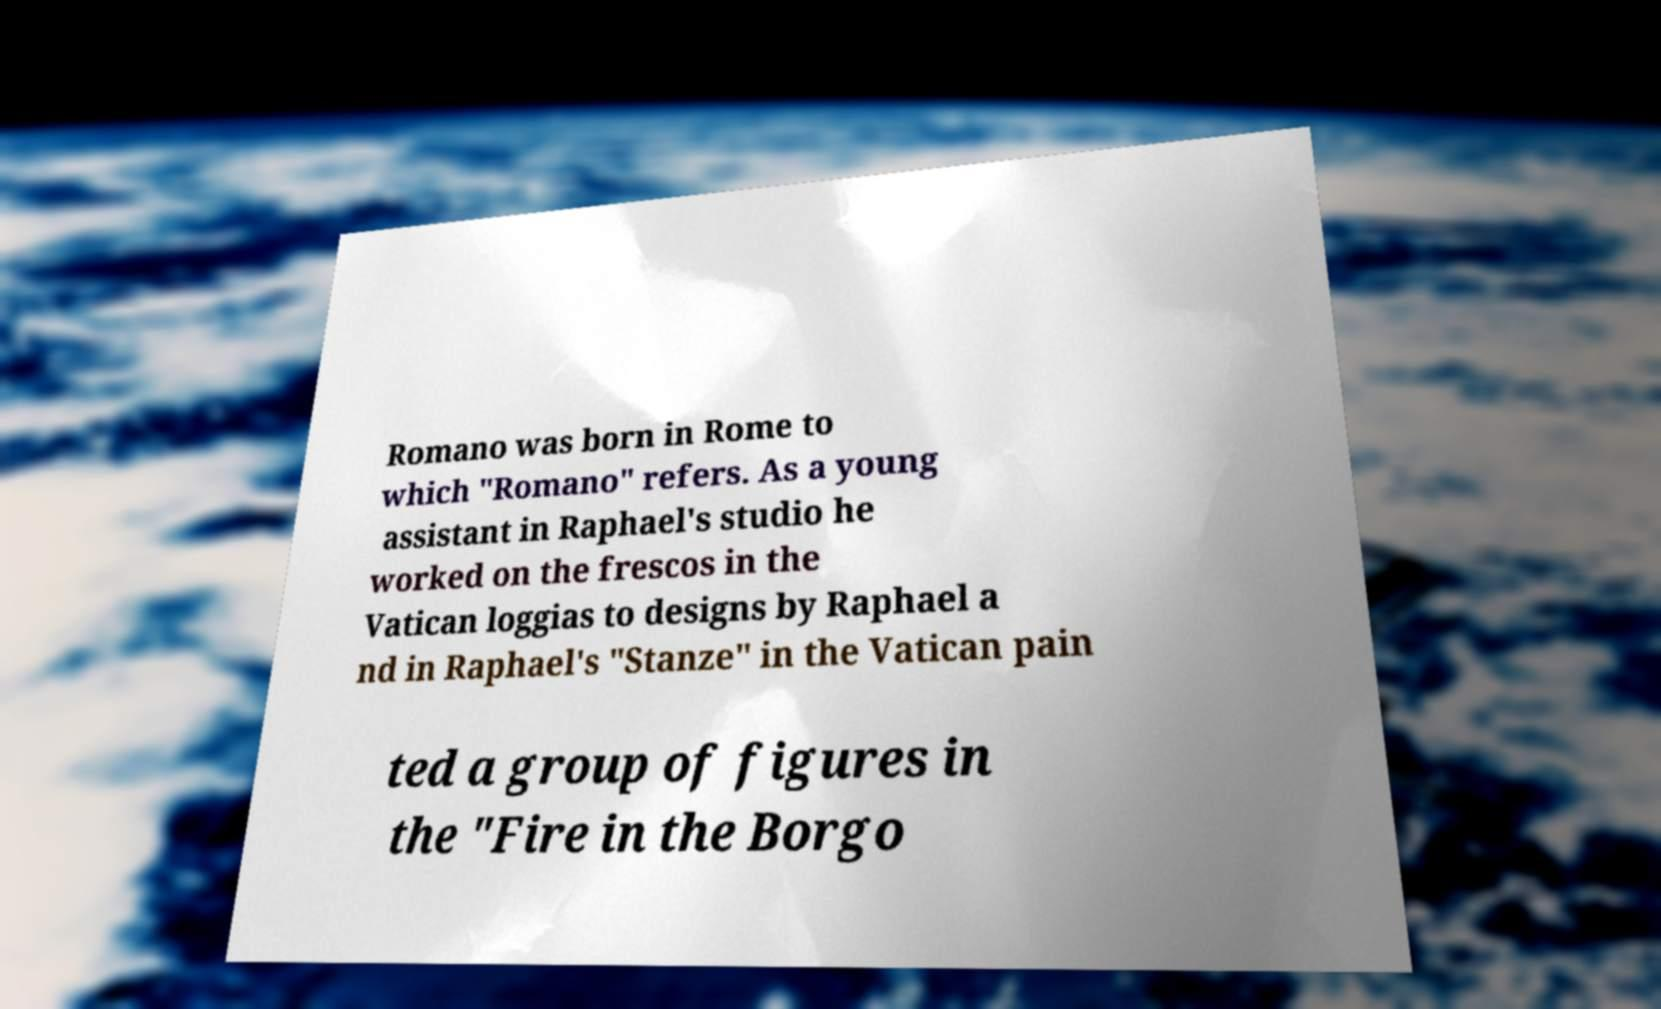Could you assist in decoding the text presented in this image and type it out clearly? Romano was born in Rome to which "Romano" refers. As a young assistant in Raphael's studio he worked on the frescos in the Vatican loggias to designs by Raphael a nd in Raphael's "Stanze" in the Vatican pain ted a group of figures in the "Fire in the Borgo 